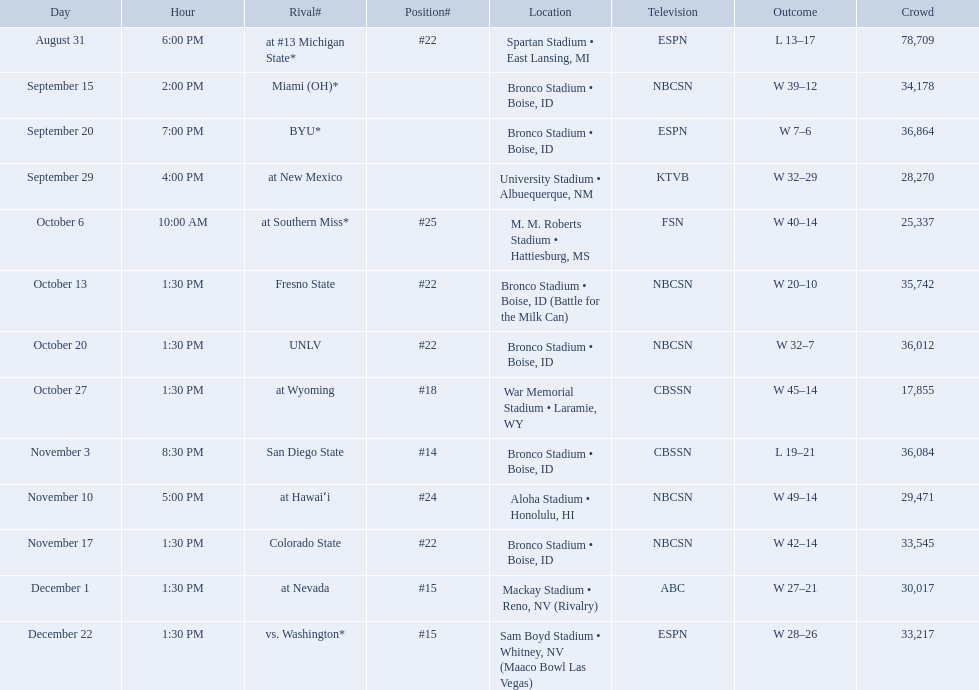What was the team's listed rankings for the season? #22, , , , #25, #22, #22, #18, #14, #24, #22, #15, #15. Which of these ranks is the best? #14. Give me the full table as a dictionary. {'header': ['Day', 'Hour', 'Rival#', 'Position#', 'Location', 'Television', 'Outcome', 'Crowd'], 'rows': [['August 31', '6:00 PM', 'at\xa0#13\xa0Michigan State*', '#22', 'Spartan Stadium • East Lansing, MI', 'ESPN', 'L\xa013–17', '78,709'], ['September 15', '2:00 PM', 'Miami (OH)*', '', 'Bronco Stadium • Boise, ID', 'NBCSN', 'W\xa039–12', '34,178'], ['September 20', '7:00 PM', 'BYU*', '', 'Bronco Stadium • Boise, ID', 'ESPN', 'W\xa07–6', '36,864'], ['September 29', '4:00 PM', 'at\xa0New Mexico', '', 'University Stadium • Albuequerque, NM', 'KTVB', 'W\xa032–29', '28,270'], ['October 6', '10:00 AM', 'at\xa0Southern Miss*', '#25', 'M. M. Roberts Stadium • Hattiesburg, MS', 'FSN', 'W\xa040–14', '25,337'], ['October 13', '1:30 PM', 'Fresno State', '#22', 'Bronco Stadium • Boise, ID (Battle for the Milk Can)', 'NBCSN', 'W\xa020–10', '35,742'], ['October 20', '1:30 PM', 'UNLV', '#22', 'Bronco Stadium • Boise, ID', 'NBCSN', 'W\xa032–7', '36,012'], ['October 27', '1:30 PM', 'at\xa0Wyoming', '#18', 'War Memorial Stadium • Laramie, WY', 'CBSSN', 'W\xa045–14', '17,855'], ['November 3', '8:30 PM', 'San Diego State', '#14', 'Bronco Stadium • Boise, ID', 'CBSSN', 'L\xa019–21', '36,084'], ['November 10', '5:00 PM', 'at\xa0Hawaiʻi', '#24', 'Aloha Stadium • Honolulu, HI', 'NBCSN', 'W\xa049–14', '29,471'], ['November 17', '1:30 PM', 'Colorado State', '#22', 'Bronco Stadium • Boise, ID', 'NBCSN', 'W\xa042–14', '33,545'], ['December 1', '1:30 PM', 'at\xa0Nevada', '#15', 'Mackay Stadium • Reno, NV (Rivalry)', 'ABC', 'W\xa027–21', '30,017'], ['December 22', '1:30 PM', 'vs.\xa0Washington*', '#15', 'Sam Boyd Stadium • Whitney, NV (Maaco Bowl Las Vegas)', 'ESPN', 'W\xa028–26', '33,217']]} What are all of the rankings? #22, , , , #25, #22, #22, #18, #14, #24, #22, #15, #15. Which of them was the best position? #14. What are the opponents to the  2012 boise state broncos football team? At #13 michigan state*, miami (oh)*, byu*, at new mexico, at southern miss*, fresno state, unlv, at wyoming, san diego state, at hawaiʻi, colorado state, at nevada, vs. washington*. Which is the highest ranked of the teams? San Diego State. Who were all the opponents for boise state? At #13 michigan state*, miami (oh)*, byu*, at new mexico, at southern miss*, fresno state, unlv, at wyoming, san diego state, at hawaiʻi, colorado state, at nevada, vs. washington*. Which opponents were ranked? At #13 michigan state*, #22, at southern miss*, #25, fresno state, #22, unlv, #22, at wyoming, #18, san diego state, #14. Which opponent had the highest rank? San Diego State. 